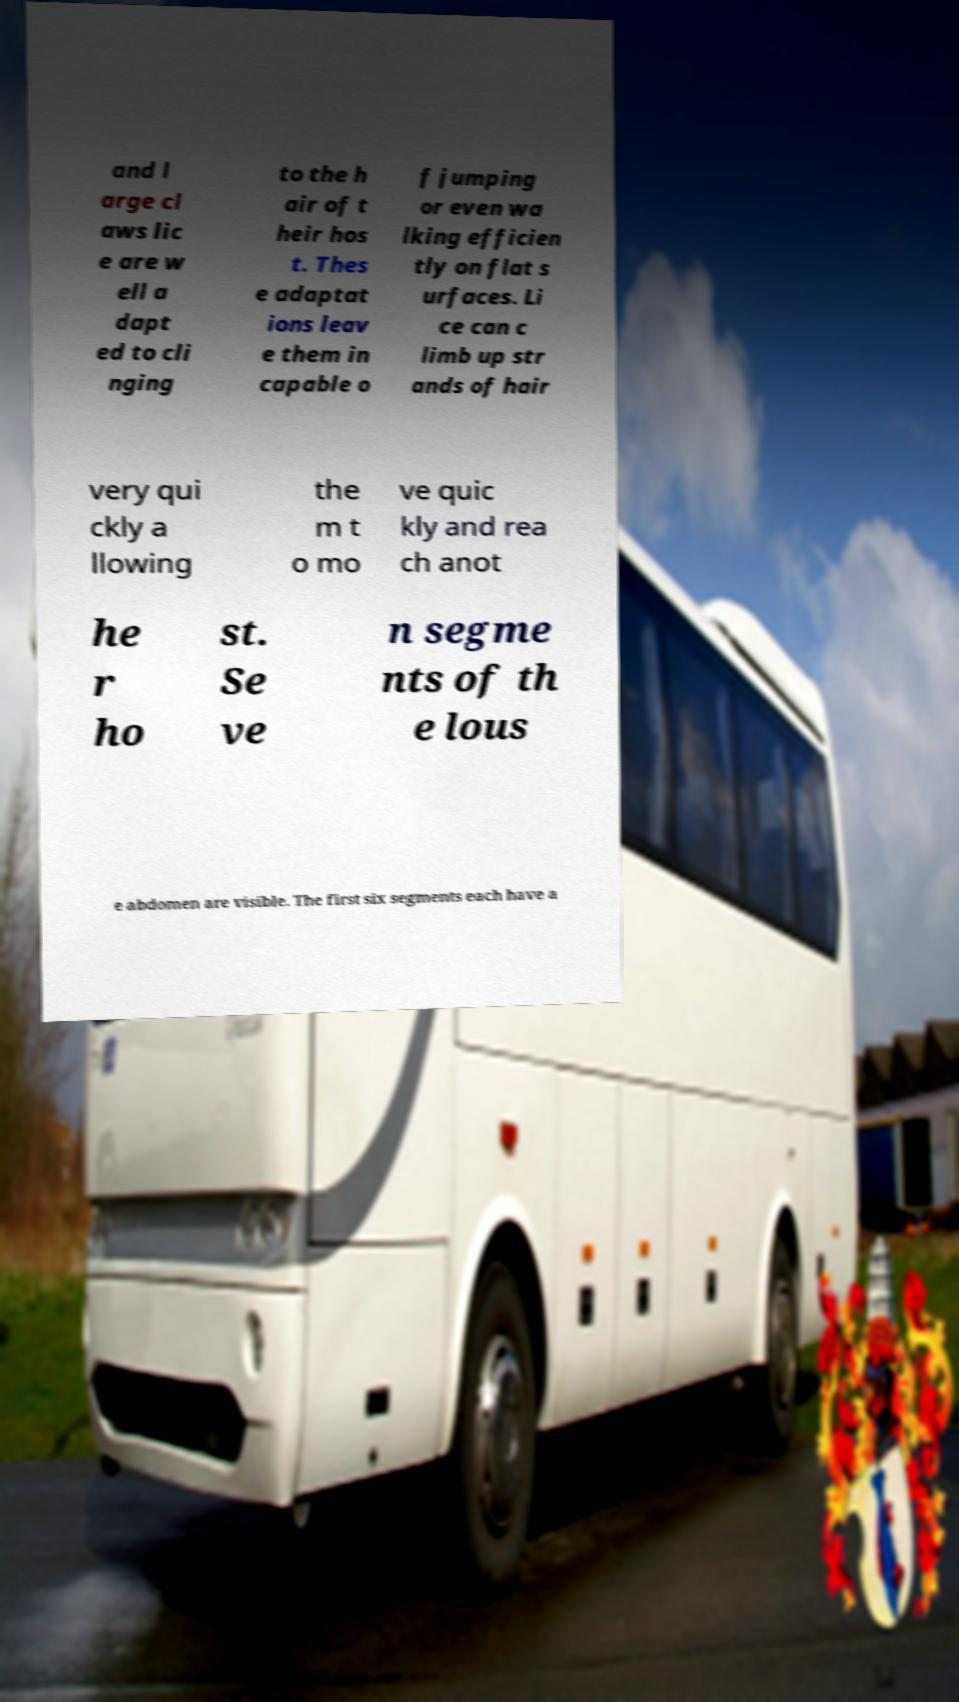Can you read and provide the text displayed in the image?This photo seems to have some interesting text. Can you extract and type it out for me? and l arge cl aws lic e are w ell a dapt ed to cli nging to the h air of t heir hos t. Thes e adaptat ions leav e them in capable o f jumping or even wa lking efficien tly on flat s urfaces. Li ce can c limb up str ands of hair very qui ckly a llowing the m t o mo ve quic kly and rea ch anot he r ho st. Se ve n segme nts of th e lous e abdomen are visible. The first six segments each have a 